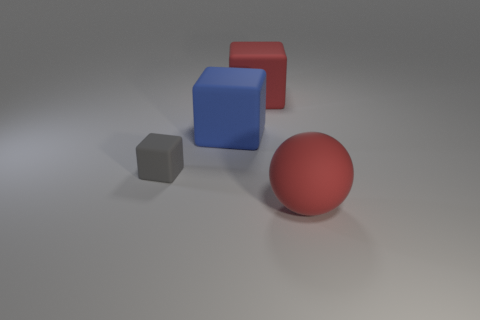How many gray objects are big balls or matte objects?
Provide a short and direct response. 1. There is a small thing that is made of the same material as the red cube; what color is it?
Offer a terse response. Gray. Do the tiny matte block and the rubber object that is in front of the tiny object have the same color?
Your answer should be very brief. No. What is the color of the block that is both in front of the red cube and to the right of the small rubber cube?
Offer a very short reply. Blue. There is a small rubber object; how many gray cubes are right of it?
Offer a very short reply. 0. What number of objects are tiny cubes or big objects that are in front of the gray object?
Offer a very short reply. 2. Are there any red matte objects that are in front of the large rubber block that is behind the large blue thing?
Your answer should be very brief. Yes. The block that is in front of the blue rubber thing is what color?
Give a very brief answer. Gray. Is the number of rubber objects that are in front of the sphere the same as the number of large red rubber balls?
Ensure brevity in your answer.  No. What is the shape of the object that is both in front of the blue rubber object and on the left side of the red block?
Provide a short and direct response. Cube. 